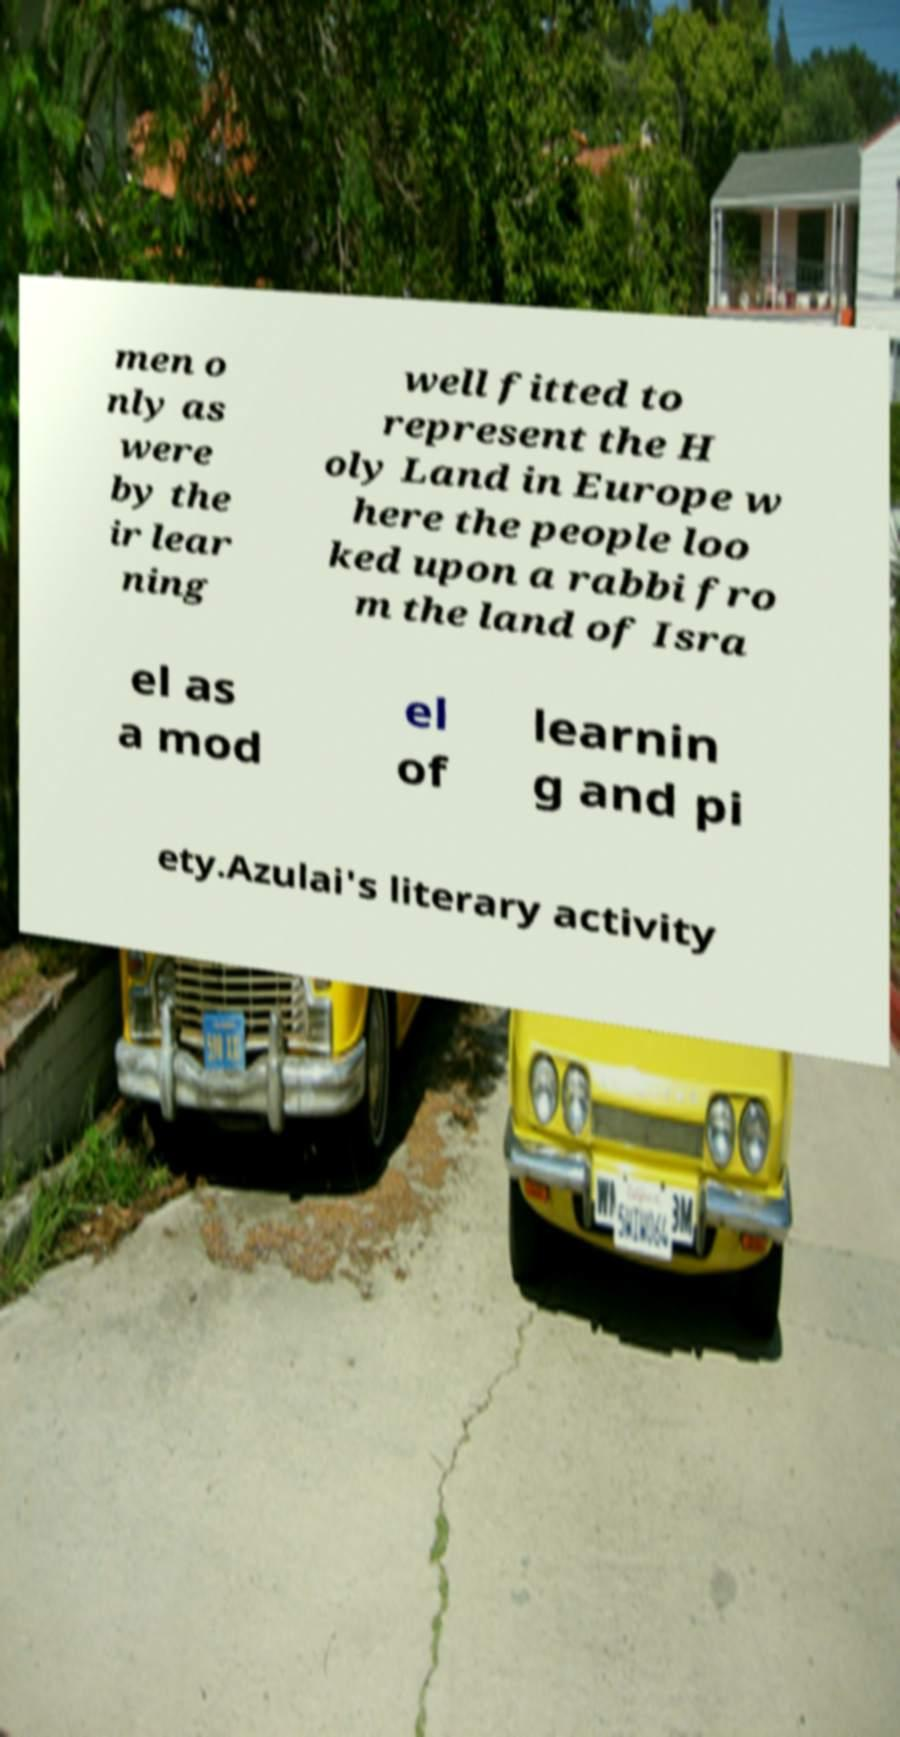Could you assist in decoding the text presented in this image and type it out clearly? men o nly as were by the ir lear ning well fitted to represent the H oly Land in Europe w here the people loo ked upon a rabbi fro m the land of Isra el as a mod el of learnin g and pi ety.Azulai's literary activity 